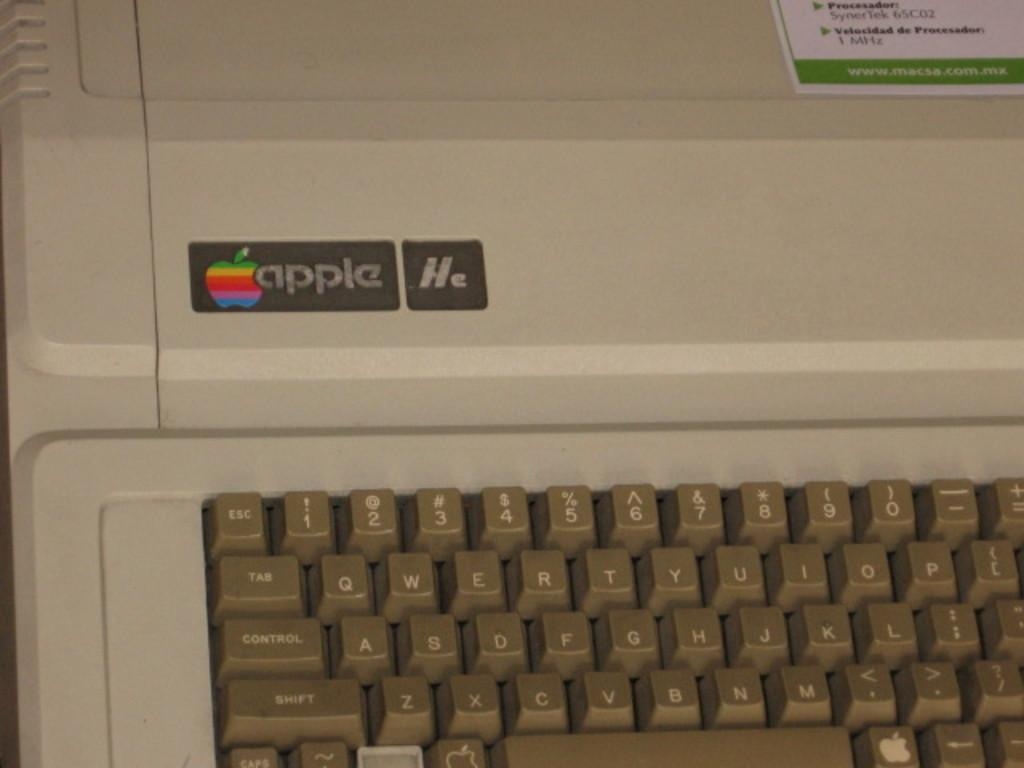Provide a one-sentence caption for the provided image. An old Apple computer that is very out of date and of no use any longer. 